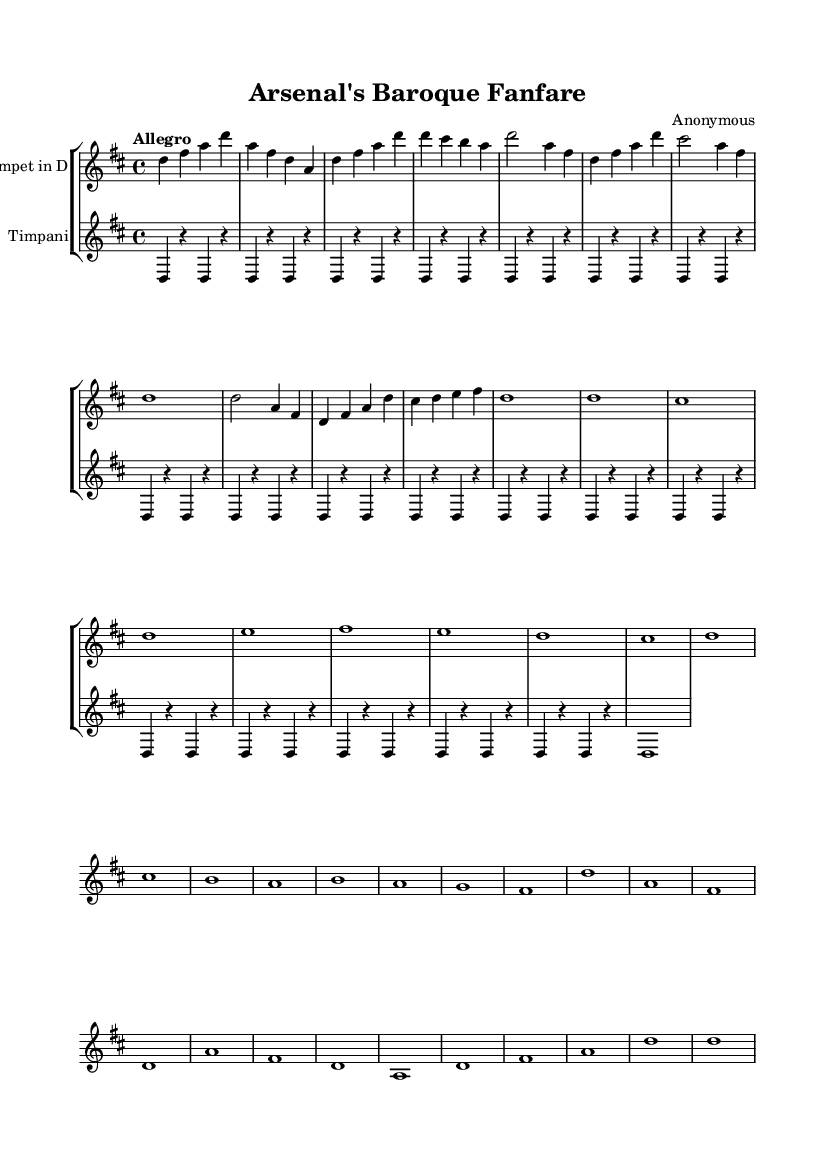What is the key signature of this music? The key signature shows two sharps (F# and C#) indicating that the piece is in D major.
Answer: D major What is the time signature of this music? The time signature is shown as 4 over 4, which means there are four beats in each measure and a quarter note gets one beat.
Answer: 4/4 What is the tempo marking for this piece? The tempo marking indicates "Allegro," which means the piece should be played at a fast tempo.
Answer: Allegro How many measures are in the main theme section? The main theme consists of 6 measures, counted from the beginning of the section to the end.
Answer: 6 What instrument plays the highest part in this score? The trumpet part is written in a higher register compared to the timpani part, which plays the lower tones.
Answer: Trumpet What is the significance of the repeated notes in the timpani part? The repeated notes in the timpani part (D) provide a solid rhythmic foundation and create a sense of anticipation, typical in fanfares.
Answer: Anticipation Identify the dynamic style suggested in this fanfare. The spirit of a Baroque fanfare is upbeat and ceremonial, often reflecting the celebratory nature of events, such as a pre-match excitement, which is conveyed through bright and bold motifs.
Answer: Ceremonial 